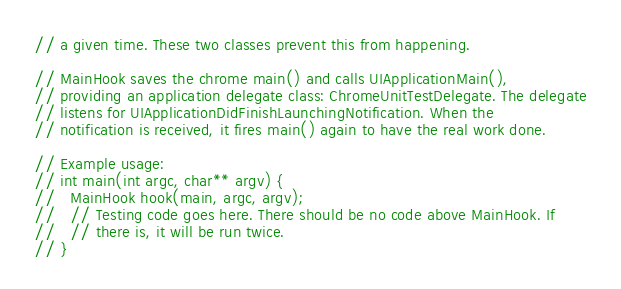Convert code to text. <code><loc_0><loc_0><loc_500><loc_500><_ObjectiveC_>// a given time. These two classes prevent this from happening.

// MainHook saves the chrome main() and calls UIApplicationMain(),
// providing an application delegate class: ChromeUnitTestDelegate. The delegate
// listens for UIApplicationDidFinishLaunchingNotification. When the
// notification is received, it fires main() again to have the real work done.

// Example usage:
// int main(int argc, char** argv) {
//   MainHook hook(main, argc, argv);
//   // Testing code goes here. There should be no code above MainHook. If
//   // there is, it will be run twice.
// }
</code> 